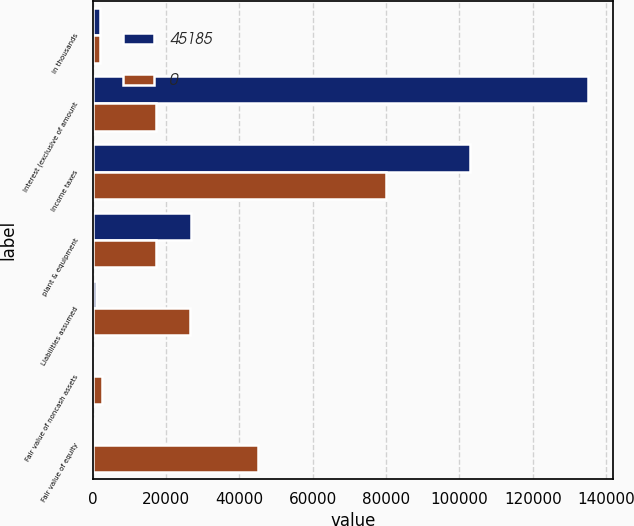Convert chart. <chart><loc_0><loc_0><loc_500><loc_500><stacked_bar_chart><ecel><fcel>in thousands<fcel>Interest (exclusive of amount<fcel>Income taxes<fcel>plant & equipment<fcel>Liabilities assumed<fcel>Fair value of noncash assets<fcel>Fair value of equity<nl><fcel>45185<fcel>2016<fcel>135039<fcel>102849<fcel>26676<fcel>798<fcel>0<fcel>0<nl><fcel>0<fcel>2014<fcel>17120<fcel>79862<fcel>17120<fcel>26622<fcel>2414<fcel>45185<nl></chart> 